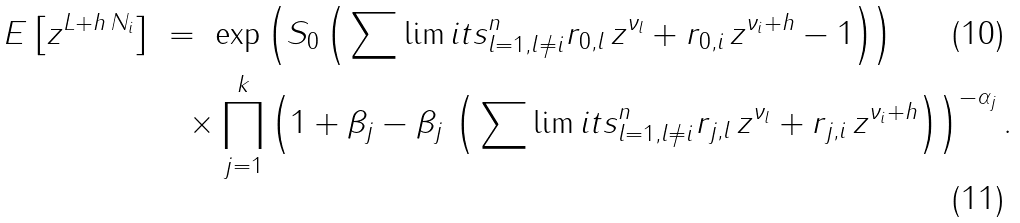Convert formula to latex. <formula><loc_0><loc_0><loc_500><loc_500>E \left [ z ^ { L + h \, N _ { i } } \right ] & \ = \ \exp \left ( S _ { 0 } \left ( \, { \sum \lim i t s _ { l = 1 , l \not = i } ^ { n } } r _ { 0 , l } \, z ^ { \nu _ { l } } + r _ { 0 , i } \, z ^ { \nu _ { i } + h } - 1 \right ) \right ) \\ & \quad \times \prod _ { j = 1 } ^ { k } \left ( 1 + \beta _ { j } - \beta _ { j } \, \left ( \, { \sum \lim i t s _ { l = 1 , l \not = i } ^ { n } } r _ { j , l } \, z ^ { \nu _ { l } } + r _ { j , i } \, z ^ { \nu _ { i } + h } \right ) \right ) ^ { - \alpha _ { j } } .</formula> 